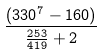Convert formula to latex. <formula><loc_0><loc_0><loc_500><loc_500>\frac { ( 3 3 0 ^ { 7 } - 1 6 0 ) } { \frac { 2 5 3 } { 4 1 9 } + 2 }</formula> 